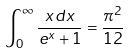<formula> <loc_0><loc_0><loc_500><loc_500>\int _ { 0 } ^ { \infty } \frac { x d x } { e ^ { x } + 1 } = \frac { \pi ^ { 2 } } { 1 2 }</formula> 